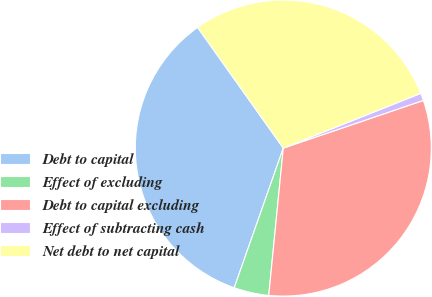Convert chart. <chart><loc_0><loc_0><loc_500><loc_500><pie_chart><fcel>Debt to capital<fcel>Effect of excluding<fcel>Debt to capital excluding<fcel>Effect of subtracting cash<fcel>Net debt to net capital<nl><fcel>34.8%<fcel>3.81%<fcel>31.79%<fcel>0.81%<fcel>28.79%<nl></chart> 